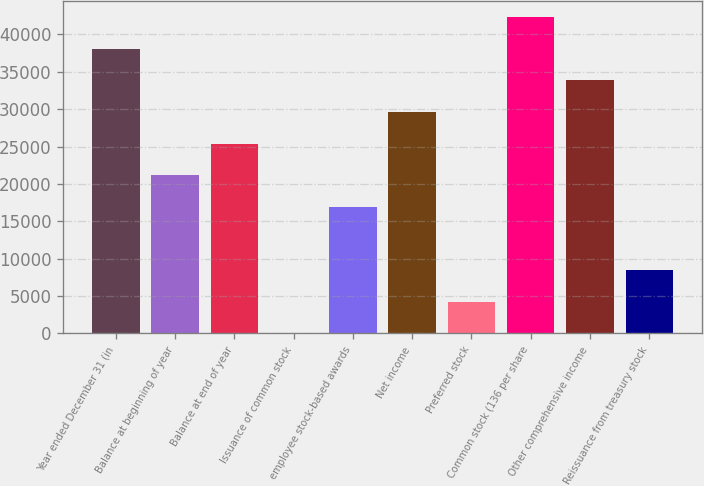Convert chart. <chart><loc_0><loc_0><loc_500><loc_500><bar_chart><fcel>Year ended December 31 (in<fcel>Balance at beginning of year<fcel>Balance at end of year<fcel>Issuance of common stock<fcel>employee stock-based awards<fcel>Net income<fcel>Preferred stock<fcel>Common stock (136 per share<fcel>Other comprehensive income<fcel>Reissuance from treasury stock<nl><fcel>38078.1<fcel>21166.5<fcel>25394.4<fcel>27<fcel>16938.6<fcel>29622.3<fcel>4254.9<fcel>42306<fcel>33850.2<fcel>8482.8<nl></chart> 